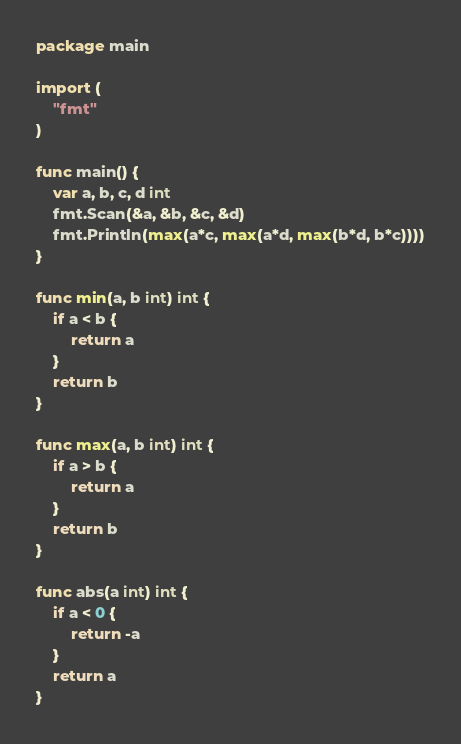<code> <loc_0><loc_0><loc_500><loc_500><_Go_>package main

import (
	"fmt"
)

func main() {
	var a, b, c, d int
	fmt.Scan(&a, &b, &c, &d)
	fmt.Println(max(a*c, max(a*d, max(b*d, b*c))))
}

func min(a, b int) int {
	if a < b {
		return a
	}
	return b
}

func max(a, b int) int {
	if a > b {
		return a
	}
	return b
}

func abs(a int) int {
	if a < 0 {
		return -a
	}
	return a
}
</code> 